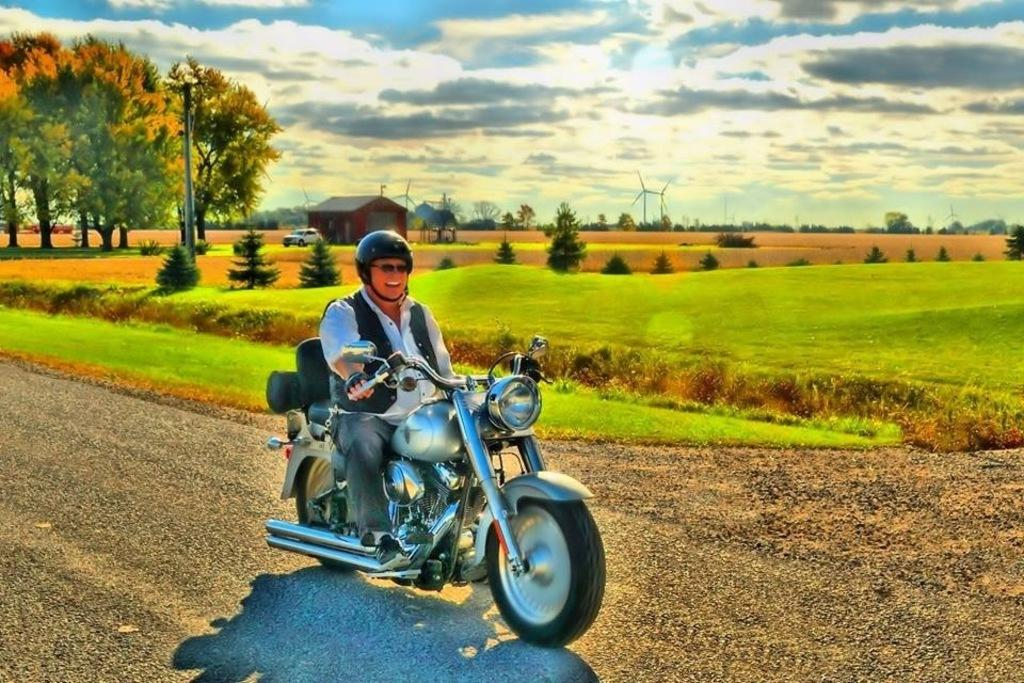What is the man in the image doing? The man is riding a bike in the image. What is the man's emotional state in the image? The man is laughing in the image. What can be seen in the background of the image? There is grass, a tree, a pole, and the sky visible in the background. What type of mint is growing on the tree in the background? There is no mint growing on the tree in the background; the tree is not described as having any specific type of plant or vegetation. 